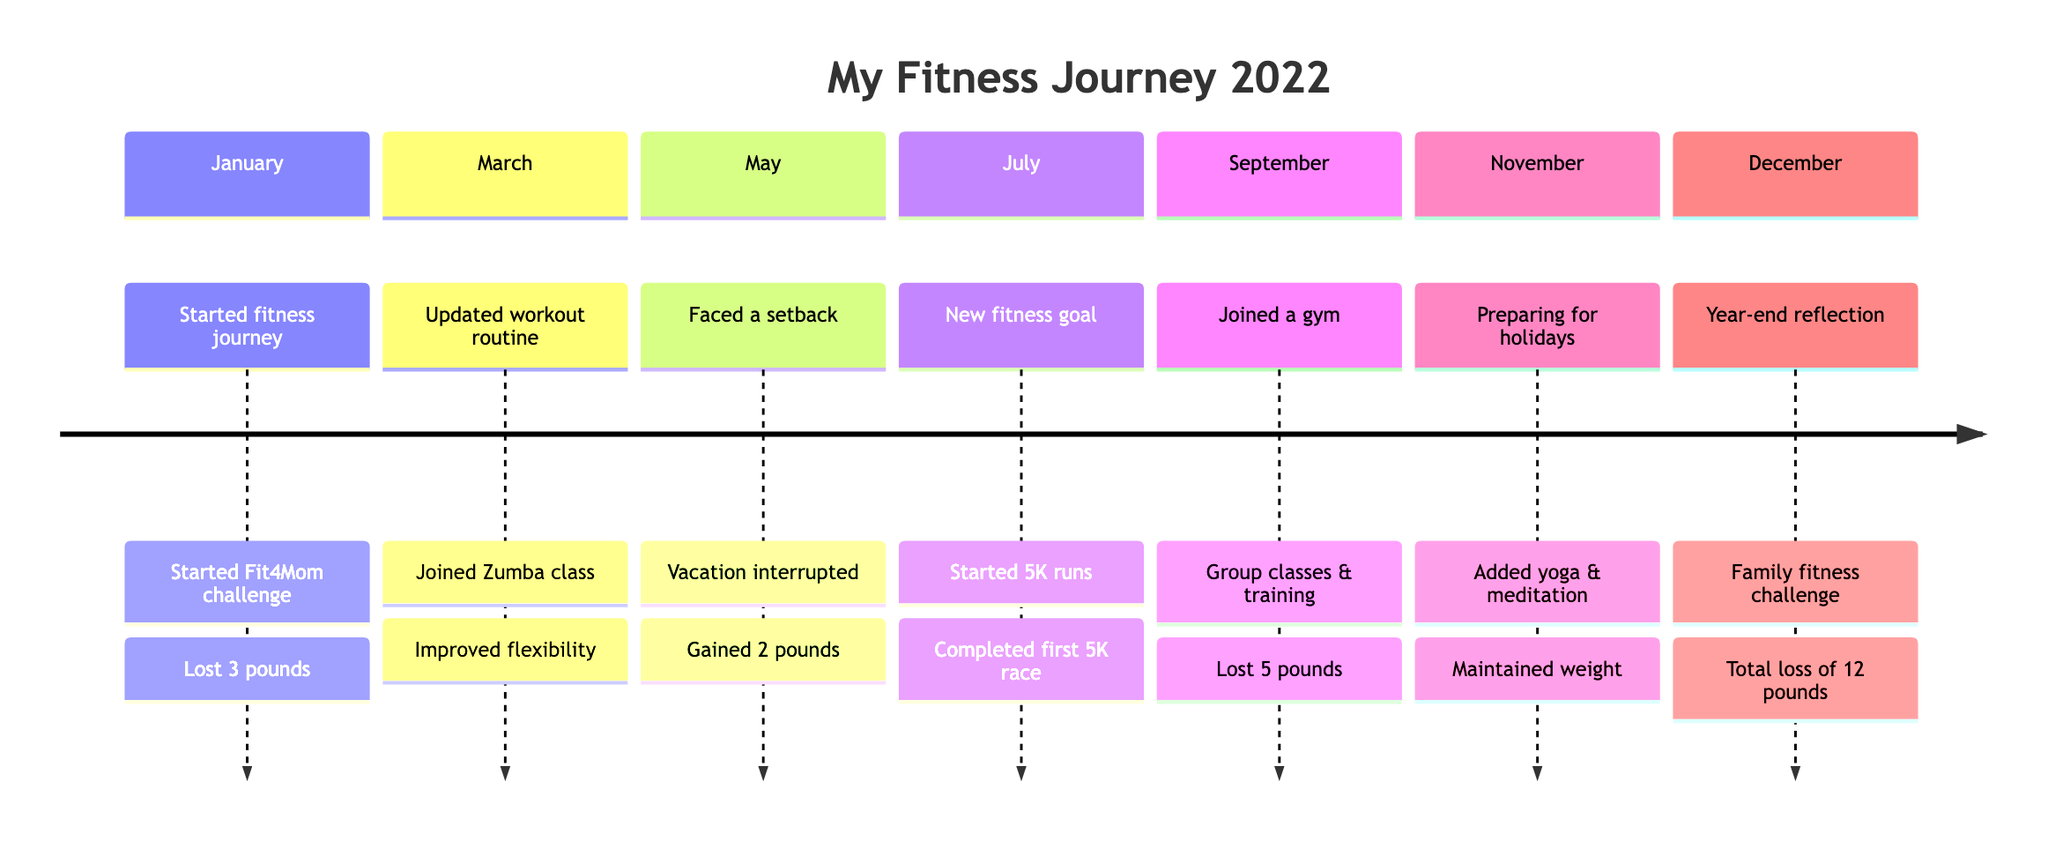What was the first milestone achieved in January? The timeline shows that the first milestone in January is "Started fitness journey." This is clear from the entry for that month, which specifically mentions starting the fitness journey as the first key event.
Answer: Started fitness journey In which month did you face a setback in your fitness journey? The timeline indicates that a setback occurred in May. It specifically states "Faced a setback" under the description for that month, indicating the struggle faced during that time.
Answer: May How many pounds did you lose by December? According to the timeline, the cumulative weight loss mentioned in December is "Lost a total of 12 pounds." This total is stated in the year-end reflection section, making it clear how much progress was made overall.
Answer: 12 pounds What new activity was introduced in July? The July section of the timeline notes the introduction of running 5K every weekend as a new fitness goal. This is described as part of the milestones achieved during that month.
Answer: Started running 5K What achievement was recorded in September? The timeline highlights in September that the achievement was "Lost 5 pounds, gained muscle tone." This is noted in connection with joining the gym and taking advantage of group classes and personal training.
Answer: Lost 5 pounds, gained muscle tone Which month includes a focus on yoga and meditation? The timeline specifies that November included "Integrated yoga and meditation to manage stress." This information can be easily found in the November section of the timeline.
Answer: November What milestone was reached in March? The milestone reached in March was "Updated workout routine." This marks the progress in the fitness journey during that month, with additional details provided about the new activities and dietary adjustments.
Answer: Updated workout routine What was the main diet focus when you first started in January? In January, the diet plan mentioned was to "Began a balanced diet focusing on whole foods and reduced sugar." This specific detail can be found in the January section of the timeline under the details of dietary changes.
Answer: Whole foods and reduced sugar 